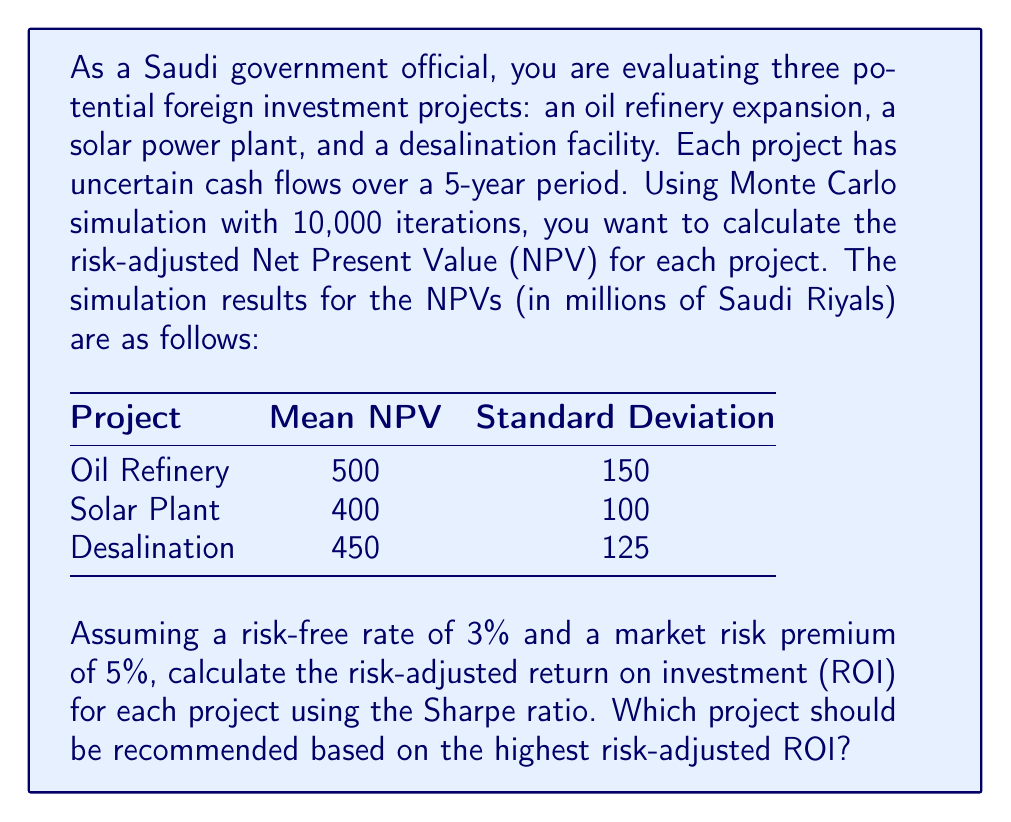Could you help me with this problem? To solve this problem, we'll follow these steps:

1. Calculate the Sharpe ratio for each project
2. Convert the Sharpe ratio to a risk-adjusted ROI
3. Compare the results and make a recommendation

Step 1: Calculate the Sharpe ratio

The Sharpe ratio is defined as:

$$ \text{Sharpe Ratio} = \frac{R_p - R_f}{\sigma_p} $$

Where:
$R_p$ = Expected return of the project
$R_f$ = Risk-free rate
$\sigma_p$ = Standard deviation of the project returns

For each project, we'll calculate the expected return as:

$$ R_p = \frac{\text{Mean NPV}}{\text{Initial Investment}} $$

Assuming an initial investment of 1000 million Saudi Riyals for each project:

Oil Refinery: $R_p = \frac{500}{1000} = 0.50$ or 50%
Solar Plant: $R_p = \frac{400}{1000} = 0.40$ or 40%
Desalination: $R_p = \frac{450}{1000} = 0.45$ or 45%

Now, we can calculate the Sharpe ratio for each project:

Oil Refinery: $\frac{0.50 - 0.03}{0.15} = 3.13$
Solar Plant: $\frac{0.40 - 0.03}{0.10} = 3.70$
Desalination: $\frac{0.45 - 0.03}{0.125} = 3.36$

Step 2: Convert Sharpe ratio to risk-adjusted ROI

To convert the Sharpe ratio to a risk-adjusted ROI, we use the formula:

$$ \text{Risk-adjusted ROI} = R_f + \text{Sharpe Ratio} \times \text{Market Risk Premium} $$

Oil Refinery: $0.03 + 3.13 \times 0.05 = 0.1865$ or 18.65%
Solar Plant: $0.03 + 3.70 \times 0.05 = 0.2150$ or 21.50%
Desalination: $0.03 + 3.36 \times 0.05 = 0.1980$ or 19.80%

Step 3: Compare results and make a recommendation

Based on the risk-adjusted ROI calculations, the Solar Plant project has the highest value at 21.50%, followed by the Desalination project at 19.80%, and the Oil Refinery project at 18.65%.
Answer: Solar Plant project with 21.50% risk-adjusted ROI 